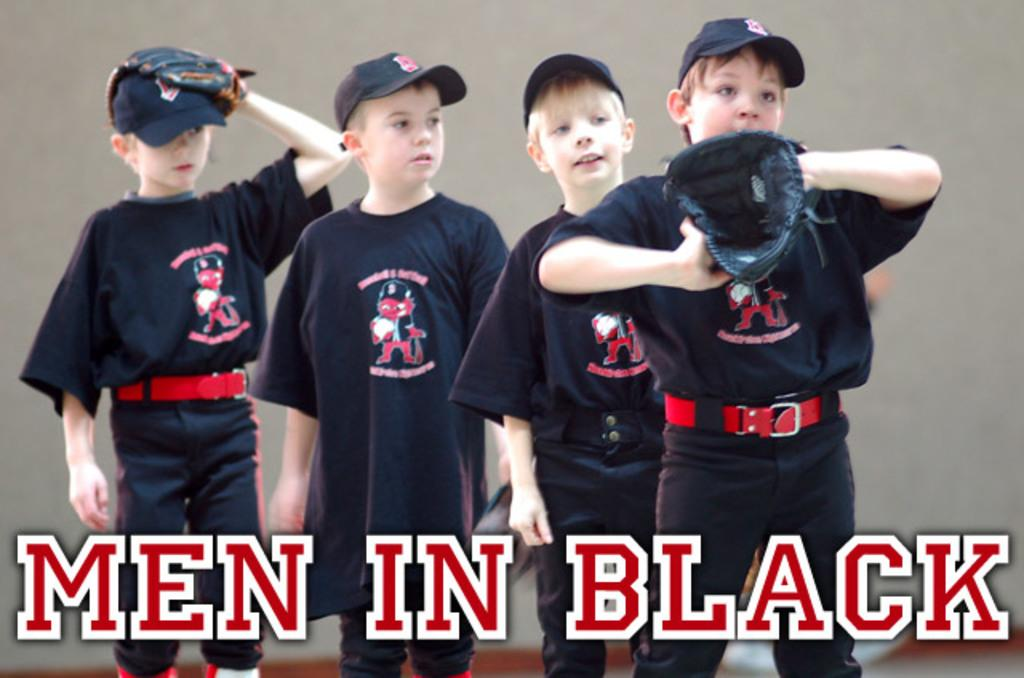Provide a one-sentence caption for the provided image. Men in black banner in white and red colors. 